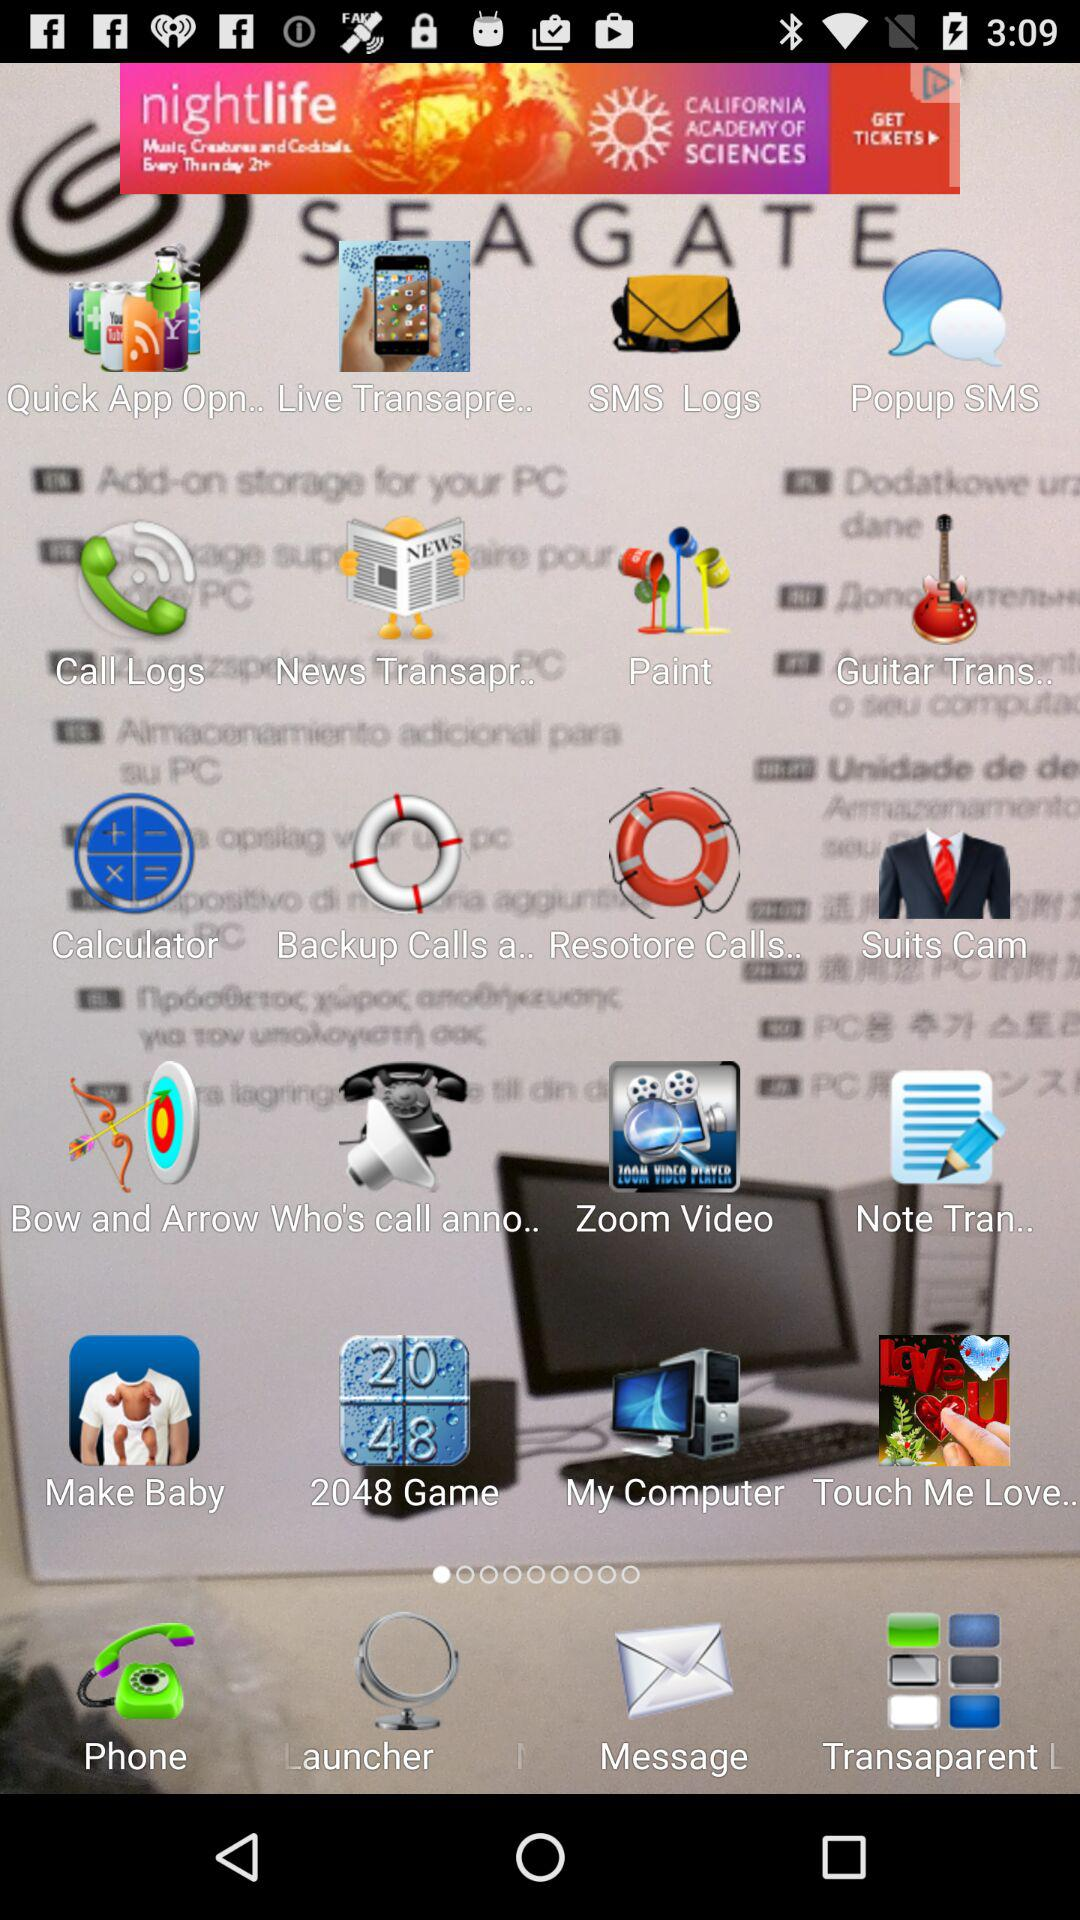What is the application name? The application name is "Transparent Screen Launcher". 